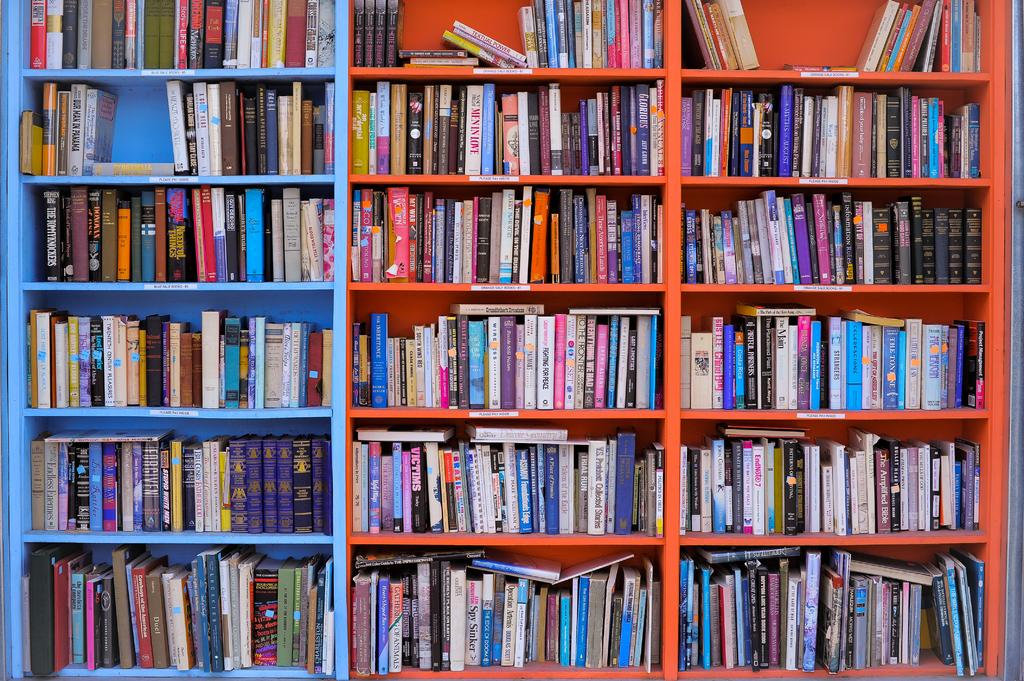What type of objects can be seen in the racks in the image? There are books in the racks in the image. What type of linen is being used to cover the books in the image? There is no linen present in the image; the books are visible in the racks. What type of music can be heard playing in the background of the image? There is no music present in the image; it only shows books in the racks. 